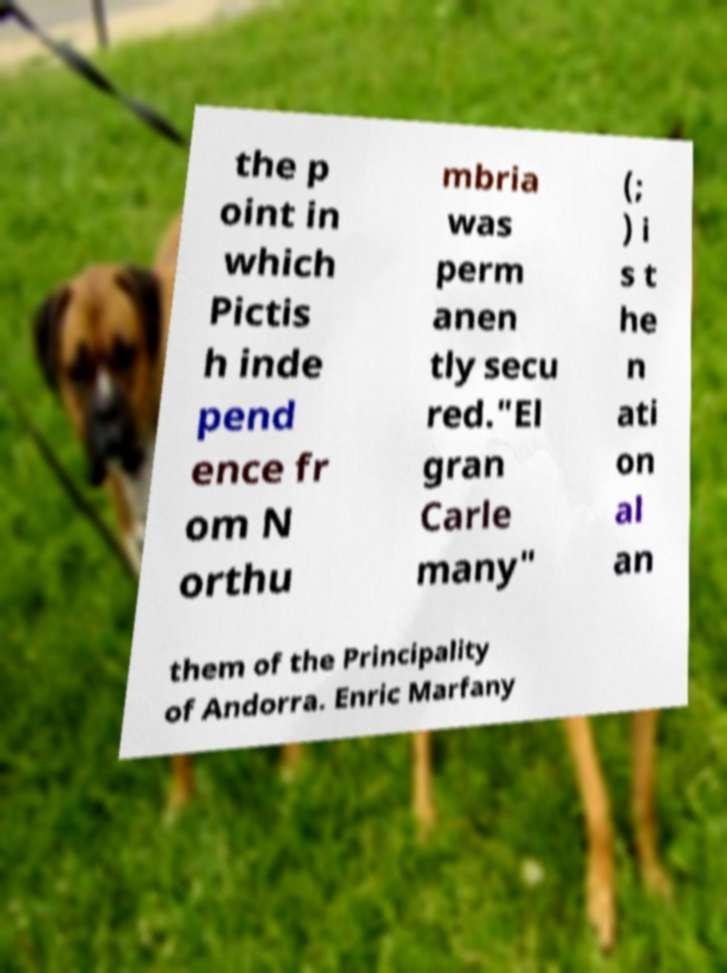Please read and relay the text visible in this image. What does it say? the p oint in which Pictis h inde pend ence fr om N orthu mbria was perm anen tly secu red."El gran Carle many" (; ) i s t he n ati on al an them of the Principality of Andorra. Enric Marfany 